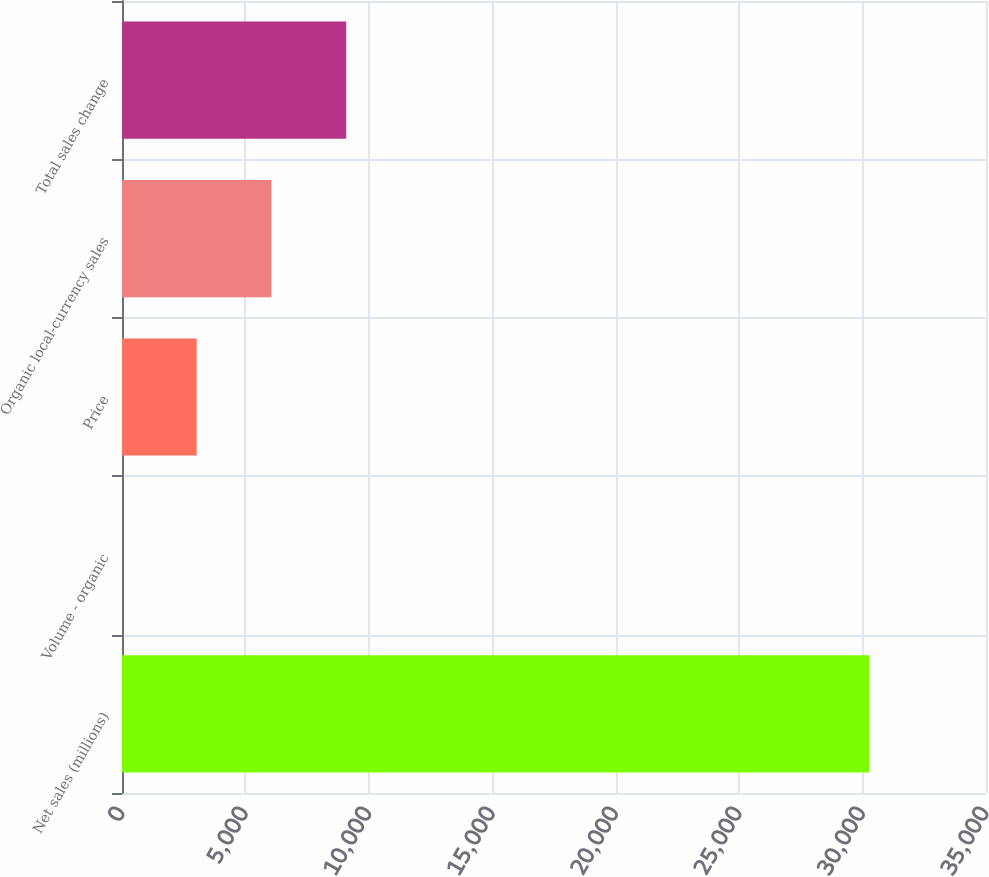Convert chart to OTSL. <chart><loc_0><loc_0><loc_500><loc_500><bar_chart><fcel>Net sales (millions)<fcel>Volume - organic<fcel>Price<fcel>Organic local-currency sales<fcel>Total sales change<nl><fcel>30274<fcel>0.2<fcel>3027.58<fcel>6054.96<fcel>9082.34<nl></chart> 